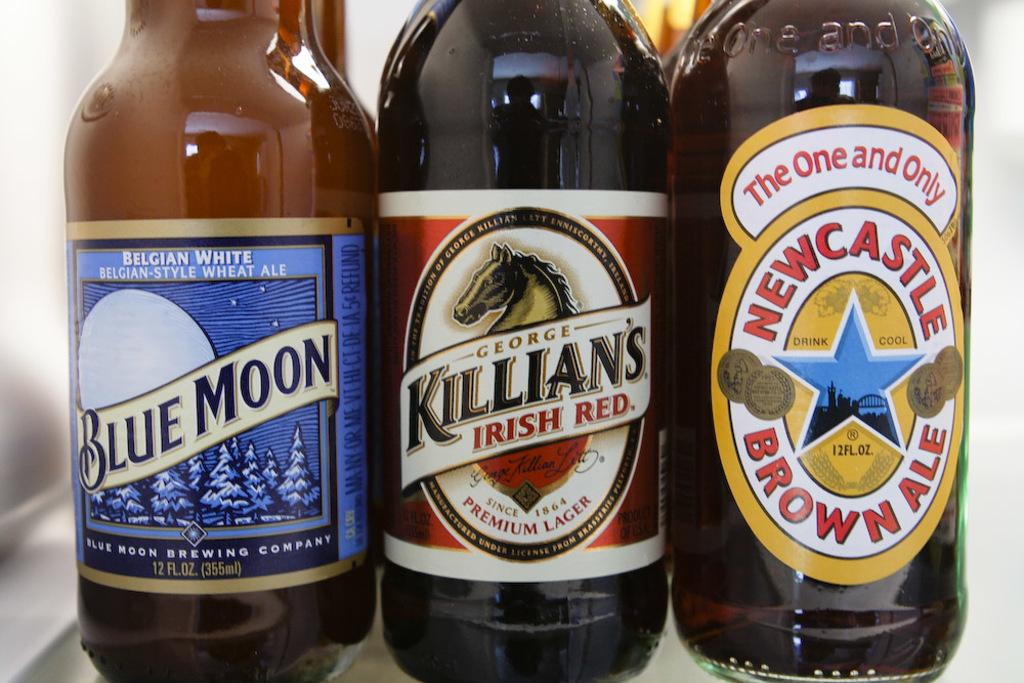Provide a one-sentence caption for the provided image. Three brown beer bottles, each with a different label displaying logos and either "Blue Moon", "Killian's Irish Red" or "Newcastle Brown Ale". 